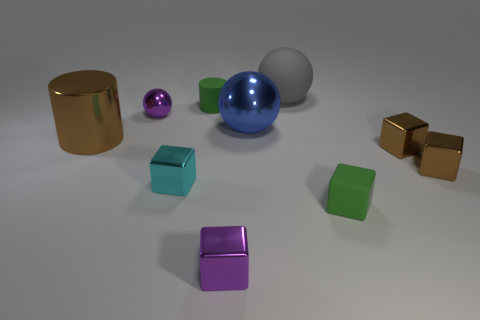Subtract 2 blocks. How many blocks are left? 3 Subtract all rubber blocks. How many blocks are left? 4 Subtract all cyan blocks. How many blocks are left? 4 Subtract all blue cubes. Subtract all green balls. How many cubes are left? 5 Subtract all cylinders. How many objects are left? 8 Add 5 small green rubber cylinders. How many small green rubber cylinders exist? 6 Subtract 1 green blocks. How many objects are left? 9 Subtract all small green matte cubes. Subtract all things. How many objects are left? 8 Add 6 cyan metal objects. How many cyan metal objects are left? 7 